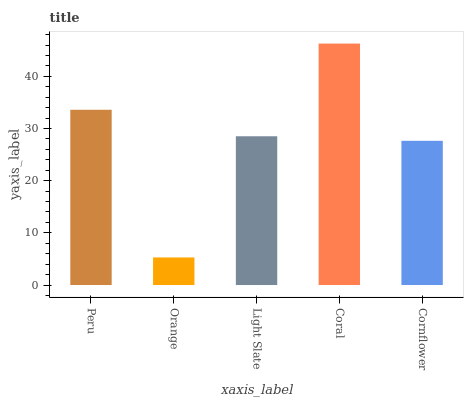Is Orange the minimum?
Answer yes or no. Yes. Is Coral the maximum?
Answer yes or no. Yes. Is Light Slate the minimum?
Answer yes or no. No. Is Light Slate the maximum?
Answer yes or no. No. Is Light Slate greater than Orange?
Answer yes or no. Yes. Is Orange less than Light Slate?
Answer yes or no. Yes. Is Orange greater than Light Slate?
Answer yes or no. No. Is Light Slate less than Orange?
Answer yes or no. No. Is Light Slate the high median?
Answer yes or no. Yes. Is Light Slate the low median?
Answer yes or no. Yes. Is Orange the high median?
Answer yes or no. No. Is Coral the low median?
Answer yes or no. No. 